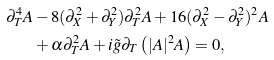<formula> <loc_0><loc_0><loc_500><loc_500>\partial _ { T } ^ { 4 } A & - 8 ( \partial _ { X } ^ { 2 } + \partial _ { Y } ^ { 2 } ) \partial _ { T } ^ { 2 } A + 1 6 ( \partial _ { X } ^ { 2 } - \partial _ { Y } ^ { 2 } ) ^ { 2 } A \\ & + \alpha \partial _ { T } ^ { 2 } A + i \tilde { g } \partial _ { T } \left ( | A | ^ { 2 } A \right ) = 0 ,</formula> 